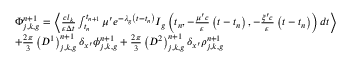<formula> <loc_0><loc_0><loc_500><loc_500>\begin{array} { l } { { \Phi _ { j , k , g } ^ { n + 1 } = \left \langle \frac { c l _ { k } } { \varepsilon \Delta t } \int _ { t _ { n } } ^ { t _ { n + 1 } } \mu ^ { \prime } e ^ { - \lambda _ { g } \left ( t - t _ { n } \right ) } I _ { g } \left ( t _ { n } , - \frac { \mu ^ { \prime } c } { \varepsilon } \left ( t - t _ { n } \right ) , - \frac { \xi ^ { \prime } c } { \varepsilon } \left ( t - t _ { n } \right ) \right ) d t \right \rangle } } \\ { { + \frac { 2 \pi } { 3 } \left ( D ^ { 1 } \right ) _ { j , k , g } ^ { n + 1 } \delta _ { x ^ { \prime } } \phi _ { j , k , g } ^ { n + 1 } + \frac { 2 \pi } { 3 } \left ( D ^ { 2 } \right ) _ { j , k , g } ^ { n + 1 } \delta _ { x ^ { \prime } } \rho _ { j , k , g } ^ { n + 1 } } } \end{array}</formula> 